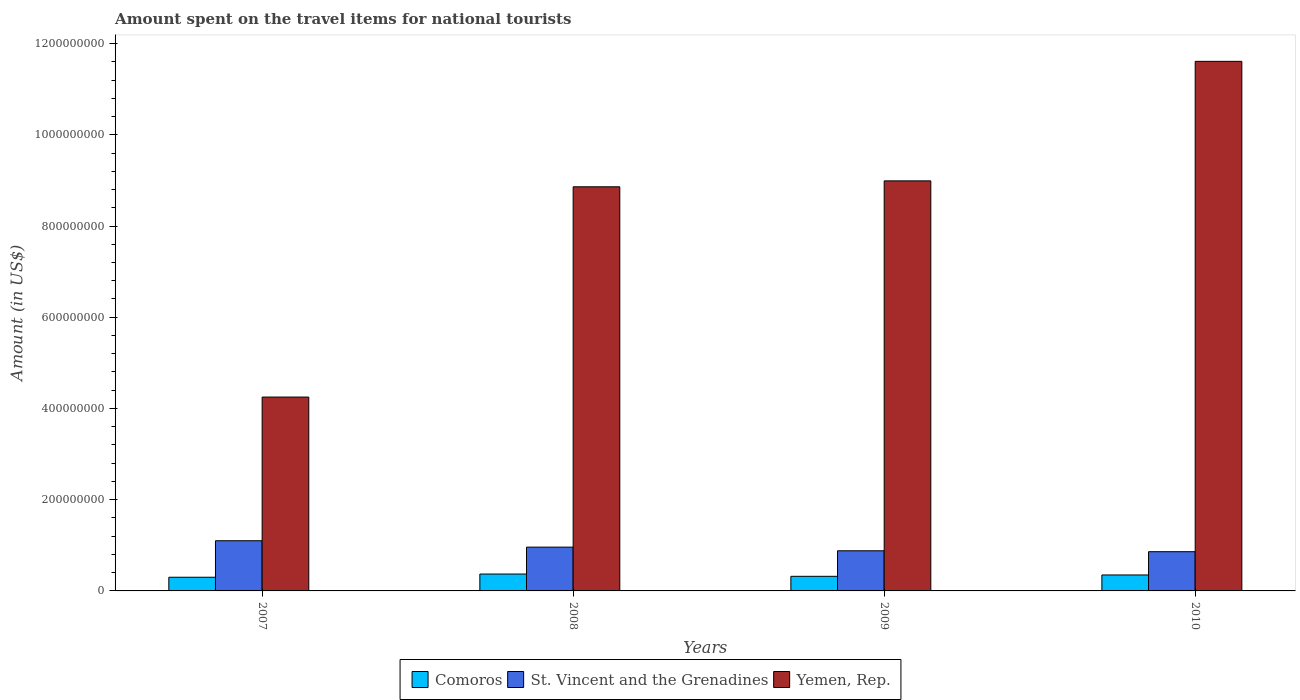How many groups of bars are there?
Your response must be concise. 4. Are the number of bars on each tick of the X-axis equal?
Offer a terse response. Yes. How many bars are there on the 3rd tick from the left?
Ensure brevity in your answer.  3. What is the amount spent on the travel items for national tourists in Yemen, Rep. in 2009?
Offer a very short reply. 8.99e+08. Across all years, what is the maximum amount spent on the travel items for national tourists in Comoros?
Provide a succinct answer. 3.70e+07. Across all years, what is the minimum amount spent on the travel items for national tourists in Comoros?
Keep it short and to the point. 3.00e+07. In which year was the amount spent on the travel items for national tourists in St. Vincent and the Grenadines maximum?
Your answer should be very brief. 2007. What is the total amount spent on the travel items for national tourists in St. Vincent and the Grenadines in the graph?
Your answer should be very brief. 3.80e+08. What is the difference between the amount spent on the travel items for national tourists in Comoros in 2010 and the amount spent on the travel items for national tourists in Yemen, Rep. in 2009?
Give a very brief answer. -8.64e+08. What is the average amount spent on the travel items for national tourists in St. Vincent and the Grenadines per year?
Offer a very short reply. 9.50e+07. In the year 2008, what is the difference between the amount spent on the travel items for national tourists in Yemen, Rep. and amount spent on the travel items for national tourists in St. Vincent and the Grenadines?
Your response must be concise. 7.90e+08. In how many years, is the amount spent on the travel items for national tourists in Comoros greater than 520000000 US$?
Provide a short and direct response. 0. What is the ratio of the amount spent on the travel items for national tourists in Comoros in 2009 to that in 2010?
Offer a very short reply. 0.91. What is the difference between the highest and the second highest amount spent on the travel items for national tourists in Yemen, Rep.?
Make the answer very short. 2.62e+08. In how many years, is the amount spent on the travel items for national tourists in St. Vincent and the Grenadines greater than the average amount spent on the travel items for national tourists in St. Vincent and the Grenadines taken over all years?
Give a very brief answer. 2. What does the 2nd bar from the left in 2010 represents?
Provide a short and direct response. St. Vincent and the Grenadines. What does the 3rd bar from the right in 2007 represents?
Make the answer very short. Comoros. Is it the case that in every year, the sum of the amount spent on the travel items for national tourists in Yemen, Rep. and amount spent on the travel items for national tourists in Comoros is greater than the amount spent on the travel items for national tourists in St. Vincent and the Grenadines?
Your answer should be very brief. Yes. Are all the bars in the graph horizontal?
Your answer should be compact. No. How many years are there in the graph?
Offer a terse response. 4. What is the difference between two consecutive major ticks on the Y-axis?
Your answer should be compact. 2.00e+08. Does the graph contain grids?
Your response must be concise. No. Where does the legend appear in the graph?
Provide a short and direct response. Bottom center. How many legend labels are there?
Offer a terse response. 3. What is the title of the graph?
Your answer should be very brief. Amount spent on the travel items for national tourists. Does "Singapore" appear as one of the legend labels in the graph?
Your answer should be very brief. No. What is the Amount (in US$) of Comoros in 2007?
Make the answer very short. 3.00e+07. What is the Amount (in US$) in St. Vincent and the Grenadines in 2007?
Offer a terse response. 1.10e+08. What is the Amount (in US$) of Yemen, Rep. in 2007?
Give a very brief answer. 4.25e+08. What is the Amount (in US$) in Comoros in 2008?
Provide a short and direct response. 3.70e+07. What is the Amount (in US$) of St. Vincent and the Grenadines in 2008?
Your answer should be compact. 9.60e+07. What is the Amount (in US$) of Yemen, Rep. in 2008?
Offer a terse response. 8.86e+08. What is the Amount (in US$) in Comoros in 2009?
Provide a short and direct response. 3.20e+07. What is the Amount (in US$) of St. Vincent and the Grenadines in 2009?
Give a very brief answer. 8.80e+07. What is the Amount (in US$) in Yemen, Rep. in 2009?
Offer a very short reply. 8.99e+08. What is the Amount (in US$) in Comoros in 2010?
Your answer should be very brief. 3.50e+07. What is the Amount (in US$) of St. Vincent and the Grenadines in 2010?
Your answer should be compact. 8.60e+07. What is the Amount (in US$) in Yemen, Rep. in 2010?
Your answer should be compact. 1.16e+09. Across all years, what is the maximum Amount (in US$) in Comoros?
Ensure brevity in your answer.  3.70e+07. Across all years, what is the maximum Amount (in US$) in St. Vincent and the Grenadines?
Offer a terse response. 1.10e+08. Across all years, what is the maximum Amount (in US$) of Yemen, Rep.?
Give a very brief answer. 1.16e+09. Across all years, what is the minimum Amount (in US$) in Comoros?
Keep it short and to the point. 3.00e+07. Across all years, what is the minimum Amount (in US$) of St. Vincent and the Grenadines?
Your answer should be compact. 8.60e+07. Across all years, what is the minimum Amount (in US$) of Yemen, Rep.?
Offer a terse response. 4.25e+08. What is the total Amount (in US$) in Comoros in the graph?
Offer a very short reply. 1.34e+08. What is the total Amount (in US$) of St. Vincent and the Grenadines in the graph?
Provide a short and direct response. 3.80e+08. What is the total Amount (in US$) in Yemen, Rep. in the graph?
Your response must be concise. 3.37e+09. What is the difference between the Amount (in US$) in Comoros in 2007 and that in 2008?
Give a very brief answer. -7.00e+06. What is the difference between the Amount (in US$) of St. Vincent and the Grenadines in 2007 and that in 2008?
Provide a succinct answer. 1.40e+07. What is the difference between the Amount (in US$) of Yemen, Rep. in 2007 and that in 2008?
Your answer should be very brief. -4.61e+08. What is the difference between the Amount (in US$) of Comoros in 2007 and that in 2009?
Provide a short and direct response. -2.00e+06. What is the difference between the Amount (in US$) of St. Vincent and the Grenadines in 2007 and that in 2009?
Provide a short and direct response. 2.20e+07. What is the difference between the Amount (in US$) in Yemen, Rep. in 2007 and that in 2009?
Offer a very short reply. -4.74e+08. What is the difference between the Amount (in US$) in Comoros in 2007 and that in 2010?
Your answer should be compact. -5.00e+06. What is the difference between the Amount (in US$) of St. Vincent and the Grenadines in 2007 and that in 2010?
Keep it short and to the point. 2.40e+07. What is the difference between the Amount (in US$) of Yemen, Rep. in 2007 and that in 2010?
Your answer should be compact. -7.36e+08. What is the difference between the Amount (in US$) in St. Vincent and the Grenadines in 2008 and that in 2009?
Your answer should be very brief. 8.00e+06. What is the difference between the Amount (in US$) of Yemen, Rep. in 2008 and that in 2009?
Provide a succinct answer. -1.30e+07. What is the difference between the Amount (in US$) of St. Vincent and the Grenadines in 2008 and that in 2010?
Make the answer very short. 1.00e+07. What is the difference between the Amount (in US$) of Yemen, Rep. in 2008 and that in 2010?
Offer a terse response. -2.75e+08. What is the difference between the Amount (in US$) in Comoros in 2009 and that in 2010?
Provide a short and direct response. -3.00e+06. What is the difference between the Amount (in US$) in St. Vincent and the Grenadines in 2009 and that in 2010?
Keep it short and to the point. 2.00e+06. What is the difference between the Amount (in US$) in Yemen, Rep. in 2009 and that in 2010?
Provide a short and direct response. -2.62e+08. What is the difference between the Amount (in US$) of Comoros in 2007 and the Amount (in US$) of St. Vincent and the Grenadines in 2008?
Keep it short and to the point. -6.60e+07. What is the difference between the Amount (in US$) in Comoros in 2007 and the Amount (in US$) in Yemen, Rep. in 2008?
Offer a very short reply. -8.56e+08. What is the difference between the Amount (in US$) of St. Vincent and the Grenadines in 2007 and the Amount (in US$) of Yemen, Rep. in 2008?
Make the answer very short. -7.76e+08. What is the difference between the Amount (in US$) in Comoros in 2007 and the Amount (in US$) in St. Vincent and the Grenadines in 2009?
Offer a terse response. -5.80e+07. What is the difference between the Amount (in US$) in Comoros in 2007 and the Amount (in US$) in Yemen, Rep. in 2009?
Make the answer very short. -8.69e+08. What is the difference between the Amount (in US$) in St. Vincent and the Grenadines in 2007 and the Amount (in US$) in Yemen, Rep. in 2009?
Provide a short and direct response. -7.89e+08. What is the difference between the Amount (in US$) of Comoros in 2007 and the Amount (in US$) of St. Vincent and the Grenadines in 2010?
Make the answer very short. -5.60e+07. What is the difference between the Amount (in US$) in Comoros in 2007 and the Amount (in US$) in Yemen, Rep. in 2010?
Provide a short and direct response. -1.13e+09. What is the difference between the Amount (in US$) in St. Vincent and the Grenadines in 2007 and the Amount (in US$) in Yemen, Rep. in 2010?
Offer a terse response. -1.05e+09. What is the difference between the Amount (in US$) of Comoros in 2008 and the Amount (in US$) of St. Vincent and the Grenadines in 2009?
Give a very brief answer. -5.10e+07. What is the difference between the Amount (in US$) in Comoros in 2008 and the Amount (in US$) in Yemen, Rep. in 2009?
Provide a short and direct response. -8.62e+08. What is the difference between the Amount (in US$) of St. Vincent and the Grenadines in 2008 and the Amount (in US$) of Yemen, Rep. in 2009?
Your answer should be very brief. -8.03e+08. What is the difference between the Amount (in US$) of Comoros in 2008 and the Amount (in US$) of St. Vincent and the Grenadines in 2010?
Your response must be concise. -4.90e+07. What is the difference between the Amount (in US$) in Comoros in 2008 and the Amount (in US$) in Yemen, Rep. in 2010?
Your answer should be very brief. -1.12e+09. What is the difference between the Amount (in US$) in St. Vincent and the Grenadines in 2008 and the Amount (in US$) in Yemen, Rep. in 2010?
Ensure brevity in your answer.  -1.06e+09. What is the difference between the Amount (in US$) in Comoros in 2009 and the Amount (in US$) in St. Vincent and the Grenadines in 2010?
Keep it short and to the point. -5.40e+07. What is the difference between the Amount (in US$) in Comoros in 2009 and the Amount (in US$) in Yemen, Rep. in 2010?
Keep it short and to the point. -1.13e+09. What is the difference between the Amount (in US$) of St. Vincent and the Grenadines in 2009 and the Amount (in US$) of Yemen, Rep. in 2010?
Provide a succinct answer. -1.07e+09. What is the average Amount (in US$) of Comoros per year?
Offer a very short reply. 3.35e+07. What is the average Amount (in US$) of St. Vincent and the Grenadines per year?
Your response must be concise. 9.50e+07. What is the average Amount (in US$) in Yemen, Rep. per year?
Ensure brevity in your answer.  8.43e+08. In the year 2007, what is the difference between the Amount (in US$) in Comoros and Amount (in US$) in St. Vincent and the Grenadines?
Provide a succinct answer. -8.00e+07. In the year 2007, what is the difference between the Amount (in US$) in Comoros and Amount (in US$) in Yemen, Rep.?
Give a very brief answer. -3.95e+08. In the year 2007, what is the difference between the Amount (in US$) in St. Vincent and the Grenadines and Amount (in US$) in Yemen, Rep.?
Offer a terse response. -3.15e+08. In the year 2008, what is the difference between the Amount (in US$) in Comoros and Amount (in US$) in St. Vincent and the Grenadines?
Offer a very short reply. -5.90e+07. In the year 2008, what is the difference between the Amount (in US$) in Comoros and Amount (in US$) in Yemen, Rep.?
Give a very brief answer. -8.49e+08. In the year 2008, what is the difference between the Amount (in US$) in St. Vincent and the Grenadines and Amount (in US$) in Yemen, Rep.?
Provide a succinct answer. -7.90e+08. In the year 2009, what is the difference between the Amount (in US$) of Comoros and Amount (in US$) of St. Vincent and the Grenadines?
Provide a succinct answer. -5.60e+07. In the year 2009, what is the difference between the Amount (in US$) of Comoros and Amount (in US$) of Yemen, Rep.?
Offer a terse response. -8.67e+08. In the year 2009, what is the difference between the Amount (in US$) in St. Vincent and the Grenadines and Amount (in US$) in Yemen, Rep.?
Keep it short and to the point. -8.11e+08. In the year 2010, what is the difference between the Amount (in US$) of Comoros and Amount (in US$) of St. Vincent and the Grenadines?
Give a very brief answer. -5.10e+07. In the year 2010, what is the difference between the Amount (in US$) of Comoros and Amount (in US$) of Yemen, Rep.?
Ensure brevity in your answer.  -1.13e+09. In the year 2010, what is the difference between the Amount (in US$) in St. Vincent and the Grenadines and Amount (in US$) in Yemen, Rep.?
Offer a terse response. -1.08e+09. What is the ratio of the Amount (in US$) in Comoros in 2007 to that in 2008?
Offer a very short reply. 0.81. What is the ratio of the Amount (in US$) in St. Vincent and the Grenadines in 2007 to that in 2008?
Provide a succinct answer. 1.15. What is the ratio of the Amount (in US$) of Yemen, Rep. in 2007 to that in 2008?
Offer a very short reply. 0.48. What is the ratio of the Amount (in US$) in Comoros in 2007 to that in 2009?
Your answer should be compact. 0.94. What is the ratio of the Amount (in US$) in Yemen, Rep. in 2007 to that in 2009?
Your answer should be compact. 0.47. What is the ratio of the Amount (in US$) of St. Vincent and the Grenadines in 2007 to that in 2010?
Offer a terse response. 1.28. What is the ratio of the Amount (in US$) of Yemen, Rep. in 2007 to that in 2010?
Offer a very short reply. 0.37. What is the ratio of the Amount (in US$) in Comoros in 2008 to that in 2009?
Provide a short and direct response. 1.16. What is the ratio of the Amount (in US$) of Yemen, Rep. in 2008 to that in 2009?
Provide a short and direct response. 0.99. What is the ratio of the Amount (in US$) in Comoros in 2008 to that in 2010?
Make the answer very short. 1.06. What is the ratio of the Amount (in US$) of St. Vincent and the Grenadines in 2008 to that in 2010?
Give a very brief answer. 1.12. What is the ratio of the Amount (in US$) of Yemen, Rep. in 2008 to that in 2010?
Offer a terse response. 0.76. What is the ratio of the Amount (in US$) in Comoros in 2009 to that in 2010?
Offer a very short reply. 0.91. What is the ratio of the Amount (in US$) in St. Vincent and the Grenadines in 2009 to that in 2010?
Ensure brevity in your answer.  1.02. What is the ratio of the Amount (in US$) of Yemen, Rep. in 2009 to that in 2010?
Provide a succinct answer. 0.77. What is the difference between the highest and the second highest Amount (in US$) in Comoros?
Provide a succinct answer. 2.00e+06. What is the difference between the highest and the second highest Amount (in US$) in St. Vincent and the Grenadines?
Offer a terse response. 1.40e+07. What is the difference between the highest and the second highest Amount (in US$) in Yemen, Rep.?
Provide a succinct answer. 2.62e+08. What is the difference between the highest and the lowest Amount (in US$) of Comoros?
Provide a short and direct response. 7.00e+06. What is the difference between the highest and the lowest Amount (in US$) of St. Vincent and the Grenadines?
Your answer should be very brief. 2.40e+07. What is the difference between the highest and the lowest Amount (in US$) of Yemen, Rep.?
Ensure brevity in your answer.  7.36e+08. 